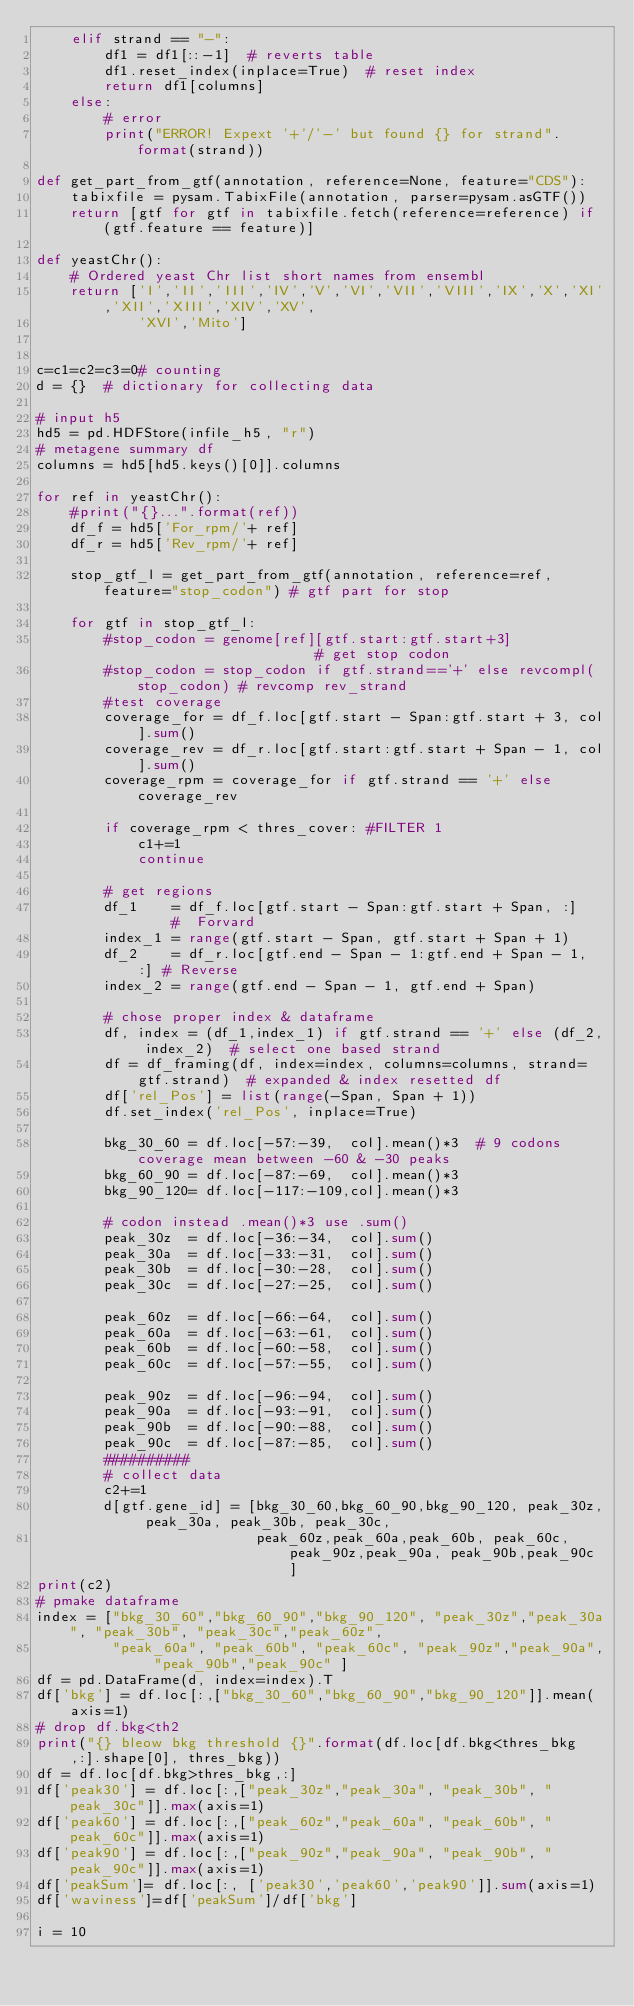<code> <loc_0><loc_0><loc_500><loc_500><_Python_>    elif strand == "-":
        df1 = df1[::-1]  # reverts table
        df1.reset_index(inplace=True)  # reset index
        return df1[columns]
    else:
        # error
        print("ERROR! Expext '+'/'-' but found {} for strand".format(strand))
        
def get_part_from_gtf(annotation, reference=None, feature="CDS"):   
    tabixfile = pysam.TabixFile(annotation, parser=pysam.asGTF())
    return [gtf for gtf in tabixfile.fetch(reference=reference) if (gtf.feature == feature)]

def yeastChr():
    # Ordered yeast Chr list short names from ensembl
    return ['I','II','III','IV','V','VI','VII','VIII','IX','X','XI','XII','XIII','XIV','XV',
            'XVI','Mito']


c=c1=c2=c3=0# counting 
d = {}  # dictionary for collecting data
 
# input h5
hd5 = pd.HDFStore(infile_h5, "r")  
# metagene summary df
columns = hd5[hd5.keys()[0]].columns

for ref in yeastChr():
    #print("{}...".format(ref))
    df_f = hd5['For_rpm/'+ ref]
    df_r = hd5['Rev_rpm/'+ ref]

    stop_gtf_l = get_part_from_gtf(annotation, reference=ref, feature="stop_codon") # gtf part for stop

    for gtf in stop_gtf_l:
        #stop_codon = genome[ref][gtf.start:gtf.start+3]                      # get stop codon
        #stop_codon = stop_codon if gtf.strand=='+' else revcompl(stop_codon) # revcomp rev_strand
        #test coverage
        coverage_for = df_f.loc[gtf.start - Span:gtf.start + 3, col].sum()
        coverage_rev = df_r.loc[gtf.start:gtf.start + Span - 1, col].sum()
        coverage_rpm = coverage_for if gtf.strand == '+' else coverage_rev

        if coverage_rpm < thres_cover: #FILTER 1
            c1+=1
            continue

        # get regions
        df_1    = df_f.loc[gtf.start - Span:gtf.start + Span, :]     #  Forvard
        index_1 = range(gtf.start - Span, gtf.start + Span + 1)
        df_2    = df_r.loc[gtf.end - Span - 1:gtf.end + Span - 1, :] # Reverse
        index_2 = range(gtf.end - Span - 1, gtf.end + Span)

        # chose proper index & dataframe
        df, index = (df_1,index_1) if gtf.strand == '+' else (df_2, index_2)  # select one based strand
        df = df_framing(df, index=index, columns=columns, strand=gtf.strand)  # expanded & index resetted df
        df['rel_Pos'] = list(range(-Span, Span + 1))
        df.set_index('rel_Pos', inplace=True)

        bkg_30_60 = df.loc[-57:-39,  col].mean()*3  # 9 codons coverage mean between -60 & -30 peaks
        bkg_60_90 = df.loc[-87:-69,  col].mean()*3
        bkg_90_120= df.loc[-117:-109,col].mean()*3
        
        # codon instead .mean()*3 use .sum()
        peak_30z  = df.loc[-36:-34,  col].sum()
        peak_30a  = df.loc[-33:-31,  col].sum()
        peak_30b  = df.loc[-30:-28,  col].sum()
        peak_30c  = df.loc[-27:-25,  col].sum()

        peak_60z  = df.loc[-66:-64,  col].sum()
        peak_60a  = df.loc[-63:-61,  col].sum()
        peak_60b  = df.loc[-60:-58,  col].sum()
        peak_60c  = df.loc[-57:-55,  col].sum()
        
        peak_90z  = df.loc[-96:-94,  col].sum()
        peak_90a  = df.loc[-93:-91,  col].sum()
        peak_90b  = df.loc[-90:-88,  col].sum()
        peak_90c  = df.loc[-87:-85,  col].sum()
        ##########
        # collect data
        c2+=1
        d[gtf.gene_id] = [bkg_30_60,bkg_60_90,bkg_90_120, peak_30z, peak_30a, peak_30b, peak_30c, 
                          peak_60z,peak_60a,peak_60b, peak_60c, peak_90z,peak_90a, peak_90b,peak_90c ]
print(c2)
# pmake dataframe
index = ["bkg_30_60","bkg_60_90","bkg_90_120", "peak_30z","peak_30a", "peak_30b", "peak_30c","peak_60z", 
         "peak_60a", "peak_60b", "peak_60c", "peak_90z","peak_90a", "peak_90b","peak_90c" ]
df = pd.DataFrame(d, index=index).T
df['bkg'] = df.loc[:,["bkg_30_60","bkg_60_90","bkg_90_120"]].mean(axis=1)
# drop df.bkg<th2
print("{} bleow bkg threshold {}".format(df.loc[df.bkg<thres_bkg,:].shape[0], thres_bkg))
df = df.loc[df.bkg>thres_bkg,:]
df['peak30'] = df.loc[:,["peak_30z","peak_30a", "peak_30b", "peak_30c"]].max(axis=1)
df['peak60'] = df.loc[:,["peak_60z","peak_60a", "peak_60b", "peak_60c"]].max(axis=1)
df['peak90'] = df.loc[:,["peak_90z","peak_90a", "peak_90b", "peak_90c"]].max(axis=1)
df['peakSum']= df.loc[:, ['peak30','peak60','peak90']].sum(axis=1)
df['waviness']=df['peakSum']/df['bkg']

i = 10 </code> 